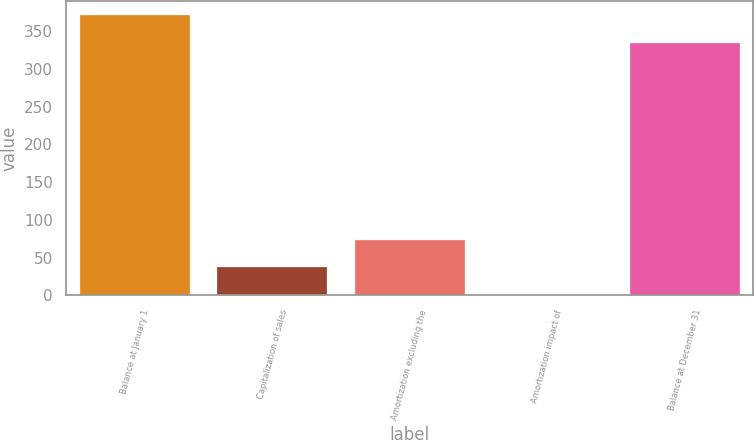<chart> <loc_0><loc_0><loc_500><loc_500><bar_chart><fcel>Balance at January 1<fcel>Capitalization of sales<fcel>Amortization excluding the<fcel>Amortization impact of<fcel>Balance at December 31<nl><fcel>371.1<fcel>37.1<fcel>73.2<fcel>1<fcel>335<nl></chart> 